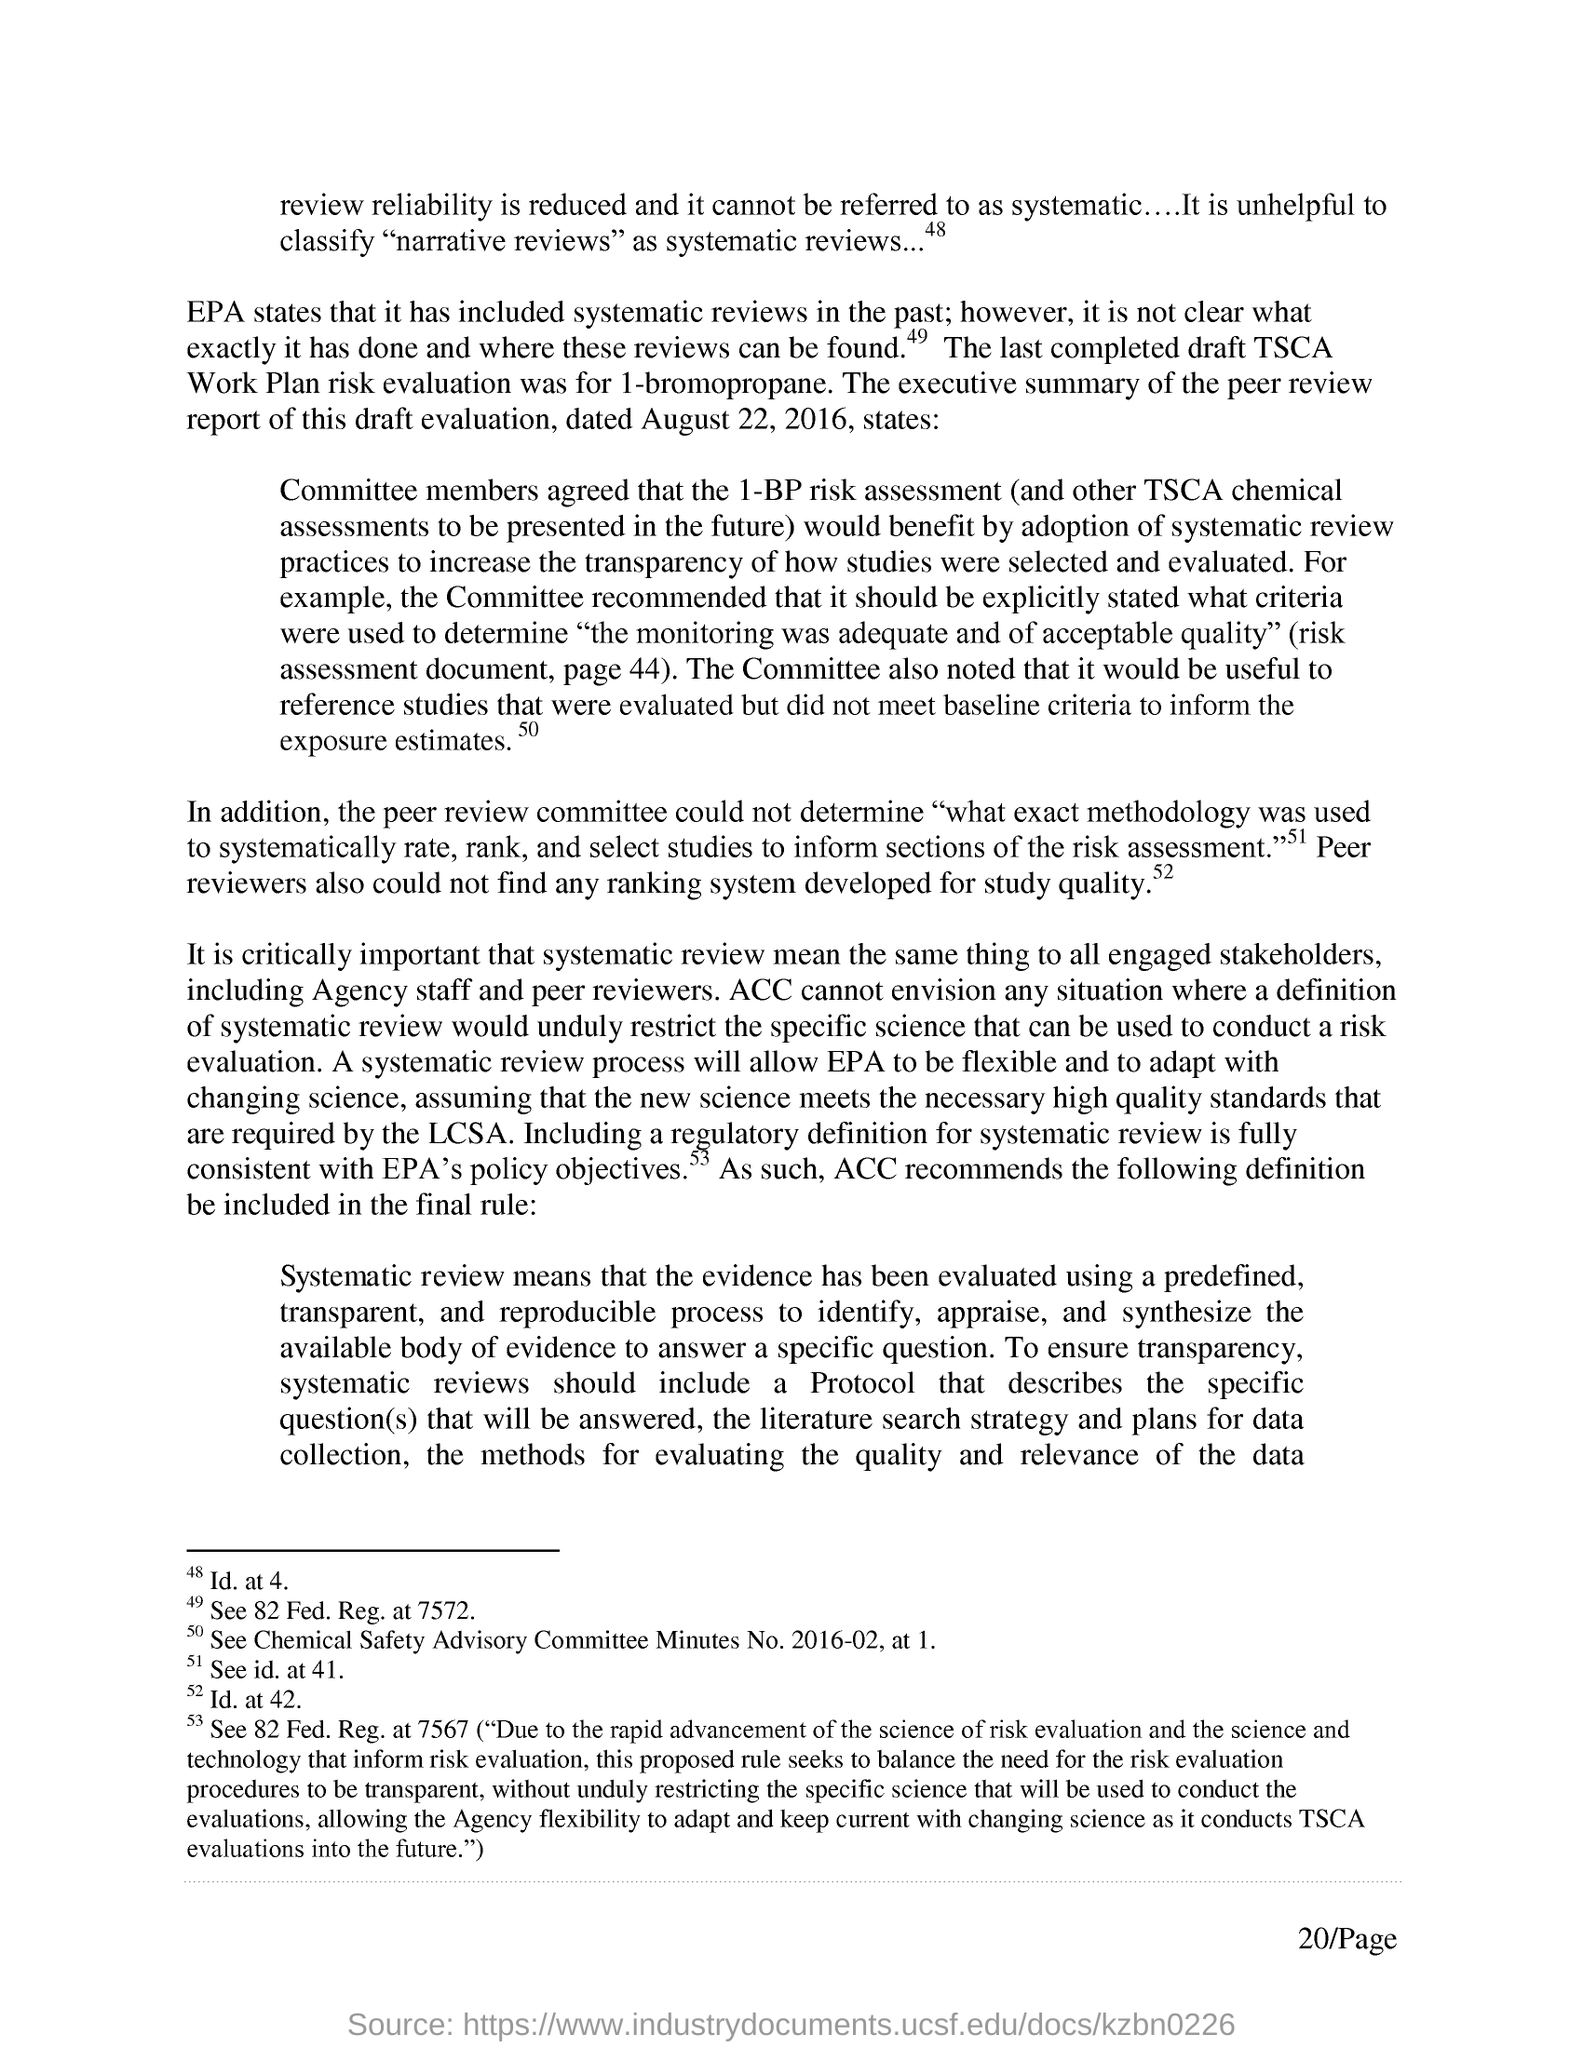Which component is used for the last completed draft TSCA Workplan RIsk Evaluation?
Provide a succinct answer. 1-bromopropane. When was the peer review report of this draft evaluation dated?
Give a very brief answer. August 22, 2016. 